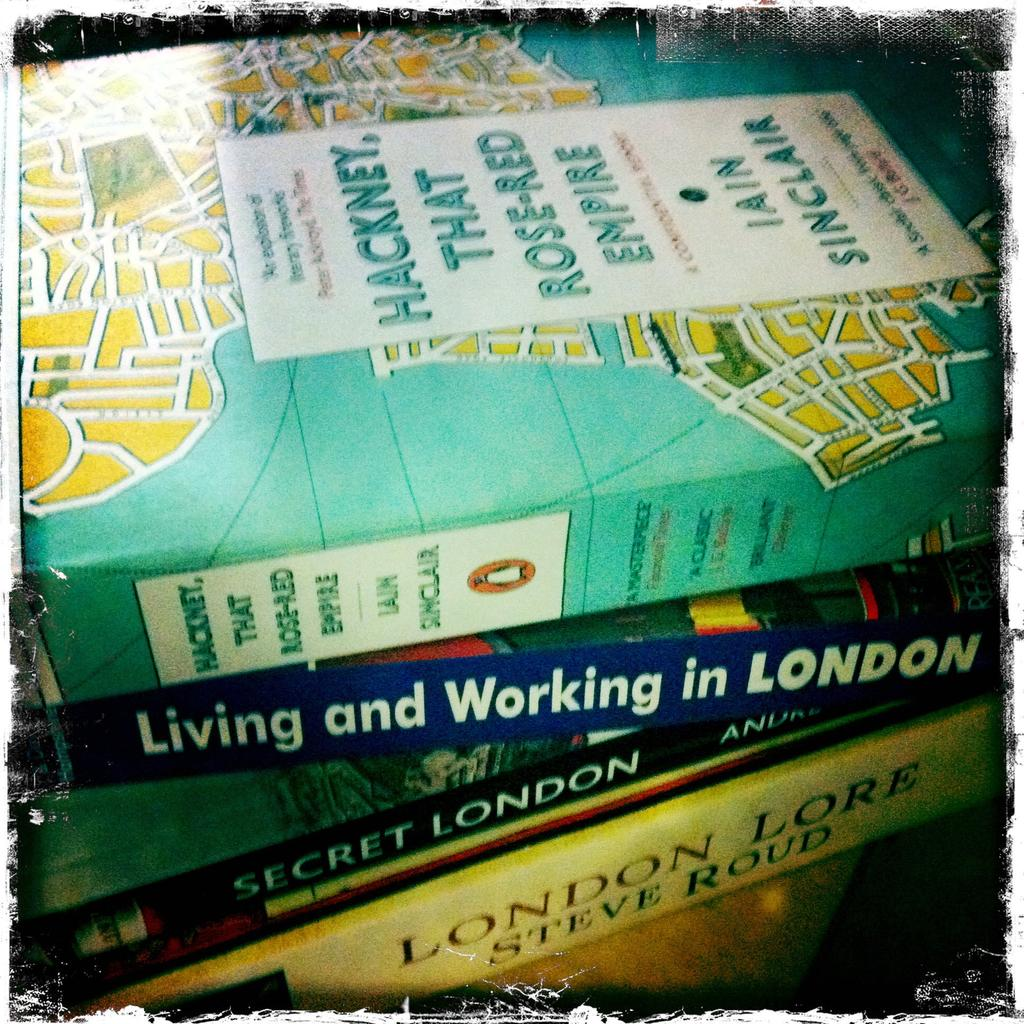Provide a one-sentence caption for the provided image. Four books stacked whose content is about London. 